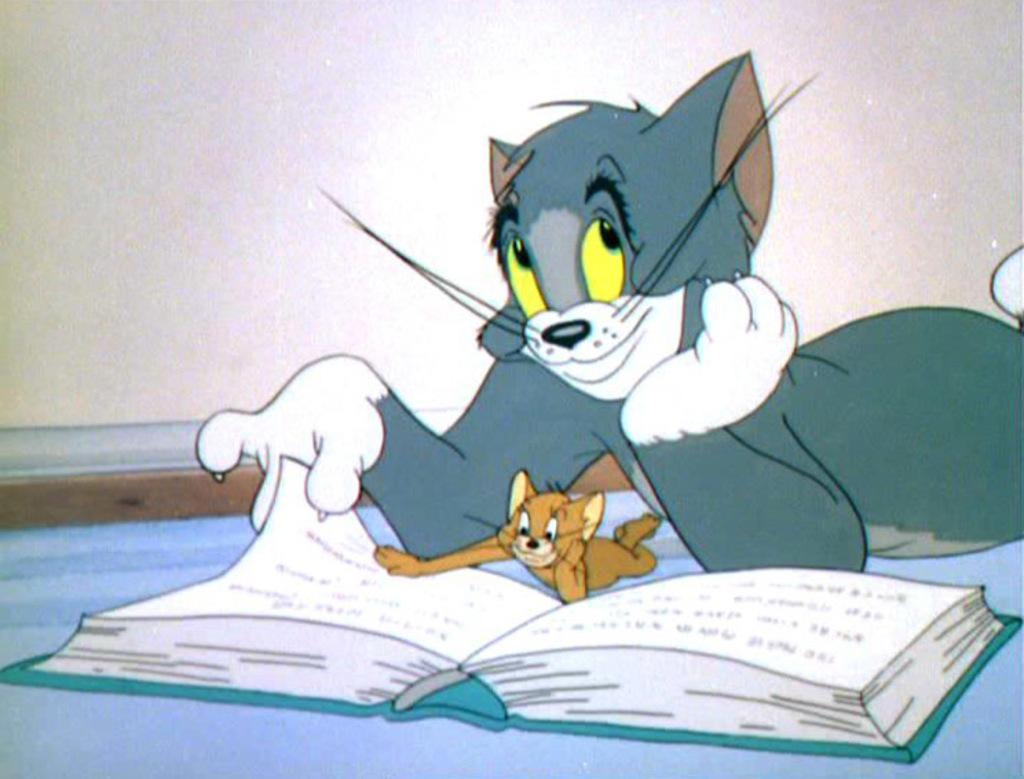What type of image is in the picture? There is a cartoon image in the picture. What object can be seen at the bottom of the image? There is a book at the bottom of the image. What animals are present in the image? There is a cat and a rat in the image. What can be seen in the background of the image? There is a wall in the background of the image. What type of horn can be seen on the cat in the image? There is no horn present on the cat in the image. Is the coal burning hot in the image? There is no coal present in the image, so it cannot be determined if it is burning hot. 